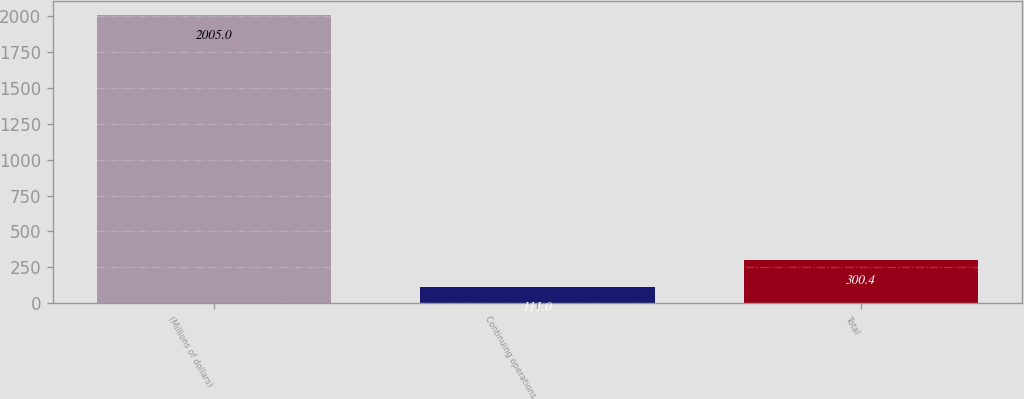<chart> <loc_0><loc_0><loc_500><loc_500><bar_chart><fcel>(Millions of dollars)<fcel>Continuing operations<fcel>Total<nl><fcel>2005<fcel>111<fcel>300.4<nl></chart> 